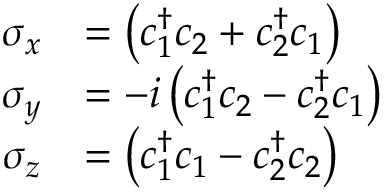Convert formula to latex. <formula><loc_0><loc_0><loc_500><loc_500>\begin{array} { r l } { \sigma _ { x } } & { = \left ( c _ { 1 } ^ { \dagger } c _ { 2 } + c _ { 2 } ^ { \dagger } c _ { 1 } \right ) } \\ { \sigma _ { y } } & { = - i \left ( c _ { 1 } ^ { \dagger } c _ { 2 } - c _ { 2 } ^ { \dagger } c _ { 1 } \right ) } \\ { \sigma _ { z } } & { = \left ( c _ { 1 } ^ { \dagger } c _ { 1 } - c _ { 2 } ^ { \dagger } c _ { 2 } \right ) } \end{array}</formula> 